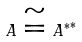<formula> <loc_0><loc_0><loc_500><loc_500>A \cong { A ^ { * } } ^ { * }</formula> 